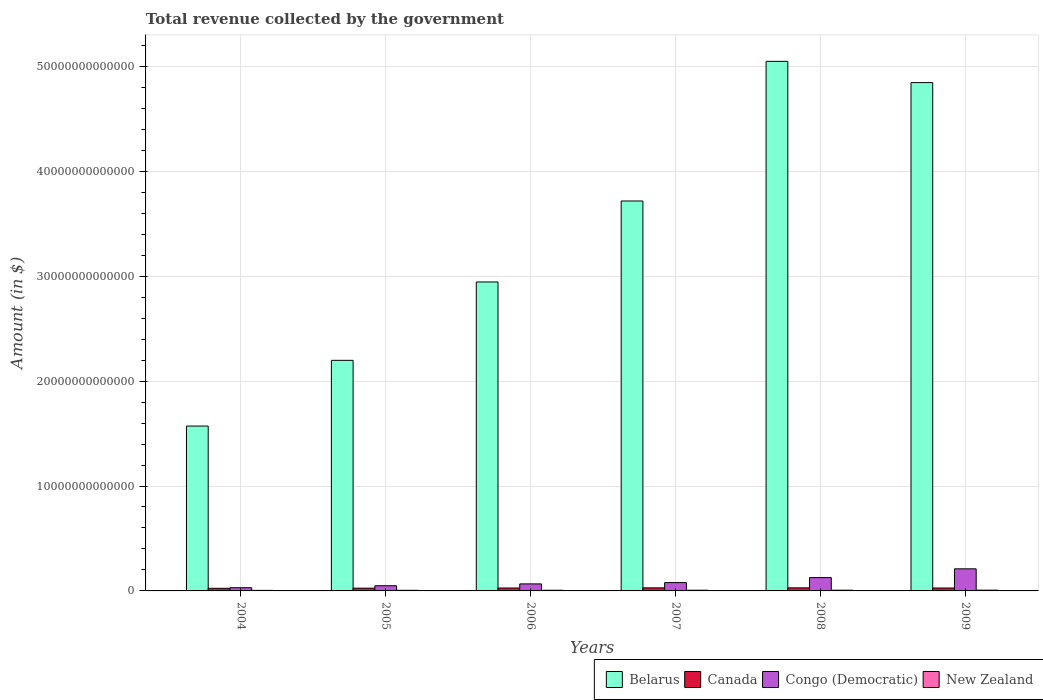How many different coloured bars are there?
Your answer should be very brief. 4. How many groups of bars are there?
Your answer should be compact. 6. What is the label of the 2nd group of bars from the left?
Provide a succinct answer. 2005. In how many cases, is the number of bars for a given year not equal to the number of legend labels?
Offer a terse response. 0. What is the total revenue collected by the government in Belarus in 2006?
Keep it short and to the point. 2.94e+13. Across all years, what is the maximum total revenue collected by the government in New Zealand?
Provide a succinct answer. 7.20e+1. Across all years, what is the minimum total revenue collected by the government in Canada?
Offer a terse response. 2.50e+11. In which year was the total revenue collected by the government in New Zealand minimum?
Offer a very short reply. 2004. What is the total total revenue collected by the government in New Zealand in the graph?
Give a very brief answer. 3.83e+11. What is the difference between the total revenue collected by the government in Belarus in 2005 and that in 2006?
Your response must be concise. -7.47e+12. What is the difference between the total revenue collected by the government in Congo (Democratic) in 2005 and the total revenue collected by the government in Canada in 2009?
Offer a very short reply. 2.18e+11. What is the average total revenue collected by the government in Belarus per year?
Your answer should be compact. 3.39e+13. In the year 2007, what is the difference between the total revenue collected by the government in Belarus and total revenue collected by the government in Congo (Democratic)?
Your answer should be very brief. 3.64e+13. What is the ratio of the total revenue collected by the government in Belarus in 2005 to that in 2009?
Your answer should be very brief. 0.45. Is the difference between the total revenue collected by the government in Belarus in 2004 and 2005 greater than the difference between the total revenue collected by the government in Congo (Democratic) in 2004 and 2005?
Your response must be concise. No. What is the difference between the highest and the second highest total revenue collected by the government in New Zealand?
Offer a very short reply. 3.18e+09. What is the difference between the highest and the lowest total revenue collected by the government in Canada?
Offer a very short reply. 4.32e+1. Is it the case that in every year, the sum of the total revenue collected by the government in New Zealand and total revenue collected by the government in Canada is greater than the sum of total revenue collected by the government in Congo (Democratic) and total revenue collected by the government in Belarus?
Make the answer very short. No. What does the 4th bar from the right in 2008 represents?
Keep it short and to the point. Belarus. Is it the case that in every year, the sum of the total revenue collected by the government in New Zealand and total revenue collected by the government in Belarus is greater than the total revenue collected by the government in Canada?
Offer a terse response. Yes. Are all the bars in the graph horizontal?
Offer a very short reply. No. What is the difference between two consecutive major ticks on the Y-axis?
Keep it short and to the point. 1.00e+13. Where does the legend appear in the graph?
Your answer should be very brief. Bottom right. How many legend labels are there?
Give a very brief answer. 4. What is the title of the graph?
Your answer should be compact. Total revenue collected by the government. What is the label or title of the Y-axis?
Keep it short and to the point. Amount (in $). What is the Amount (in $) of Belarus in 2004?
Make the answer very short. 1.57e+13. What is the Amount (in $) in Canada in 2004?
Provide a short and direct response. 2.50e+11. What is the Amount (in $) of Congo (Democratic) in 2004?
Make the answer very short. 3.06e+11. What is the Amount (in $) of New Zealand in 2004?
Offer a terse response. 5.34e+1. What is the Amount (in $) in Belarus in 2005?
Your answer should be compact. 2.20e+13. What is the Amount (in $) in Canada in 2005?
Your answer should be compact. 2.63e+11. What is the Amount (in $) of Congo (Democratic) in 2005?
Your answer should be compact. 4.95e+11. What is the Amount (in $) in New Zealand in 2005?
Offer a terse response. 5.89e+1. What is the Amount (in $) of Belarus in 2006?
Offer a very short reply. 2.94e+13. What is the Amount (in $) of Canada in 2006?
Provide a succinct answer. 2.77e+11. What is the Amount (in $) of Congo (Democratic) in 2006?
Make the answer very short. 6.69e+11. What is the Amount (in $) in New Zealand in 2006?
Offer a terse response. 6.38e+1. What is the Amount (in $) of Belarus in 2007?
Make the answer very short. 3.72e+13. What is the Amount (in $) of Canada in 2007?
Provide a succinct answer. 2.93e+11. What is the Amount (in $) of Congo (Democratic) in 2007?
Give a very brief answer. 7.94e+11. What is the Amount (in $) in New Zealand in 2007?
Make the answer very short. 6.59e+1. What is the Amount (in $) of Belarus in 2008?
Offer a terse response. 5.05e+13. What is the Amount (in $) in Canada in 2008?
Provide a succinct answer. 2.93e+11. What is the Amount (in $) in Congo (Democratic) in 2008?
Your response must be concise. 1.27e+12. What is the Amount (in $) of New Zealand in 2008?
Provide a short and direct response. 6.88e+1. What is the Amount (in $) of Belarus in 2009?
Offer a very short reply. 4.85e+13. What is the Amount (in $) in Canada in 2009?
Your response must be concise. 2.77e+11. What is the Amount (in $) of Congo (Democratic) in 2009?
Provide a succinct answer. 2.10e+12. What is the Amount (in $) in New Zealand in 2009?
Provide a succinct answer. 7.20e+1. Across all years, what is the maximum Amount (in $) in Belarus?
Offer a terse response. 5.05e+13. Across all years, what is the maximum Amount (in $) of Canada?
Offer a very short reply. 2.93e+11. Across all years, what is the maximum Amount (in $) in Congo (Democratic)?
Your answer should be compact. 2.10e+12. Across all years, what is the maximum Amount (in $) of New Zealand?
Your response must be concise. 7.20e+1. Across all years, what is the minimum Amount (in $) of Belarus?
Offer a terse response. 1.57e+13. Across all years, what is the minimum Amount (in $) of Canada?
Your answer should be very brief. 2.50e+11. Across all years, what is the minimum Amount (in $) of Congo (Democratic)?
Your answer should be compact. 3.06e+11. Across all years, what is the minimum Amount (in $) of New Zealand?
Ensure brevity in your answer.  5.34e+1. What is the total Amount (in $) of Belarus in the graph?
Ensure brevity in your answer.  2.03e+14. What is the total Amount (in $) in Canada in the graph?
Make the answer very short. 1.65e+12. What is the total Amount (in $) of Congo (Democratic) in the graph?
Keep it short and to the point. 5.64e+12. What is the total Amount (in $) of New Zealand in the graph?
Ensure brevity in your answer.  3.83e+11. What is the difference between the Amount (in $) in Belarus in 2004 and that in 2005?
Provide a succinct answer. -6.26e+12. What is the difference between the Amount (in $) in Canada in 2004 and that in 2005?
Ensure brevity in your answer.  -1.37e+1. What is the difference between the Amount (in $) in Congo (Democratic) in 2004 and that in 2005?
Provide a short and direct response. -1.89e+11. What is the difference between the Amount (in $) of New Zealand in 2004 and that in 2005?
Provide a short and direct response. -5.52e+09. What is the difference between the Amount (in $) in Belarus in 2004 and that in 2006?
Ensure brevity in your answer.  -1.37e+13. What is the difference between the Amount (in $) in Canada in 2004 and that in 2006?
Ensure brevity in your answer.  -2.77e+1. What is the difference between the Amount (in $) in Congo (Democratic) in 2004 and that in 2006?
Your answer should be very brief. -3.63e+11. What is the difference between the Amount (in $) in New Zealand in 2004 and that in 2006?
Ensure brevity in your answer.  -1.03e+1. What is the difference between the Amount (in $) in Belarus in 2004 and that in 2007?
Offer a very short reply. -2.15e+13. What is the difference between the Amount (in $) in Canada in 2004 and that in 2007?
Keep it short and to the point. -4.32e+1. What is the difference between the Amount (in $) of Congo (Democratic) in 2004 and that in 2007?
Your answer should be very brief. -4.88e+11. What is the difference between the Amount (in $) in New Zealand in 2004 and that in 2007?
Make the answer very short. -1.24e+1. What is the difference between the Amount (in $) of Belarus in 2004 and that in 2008?
Your answer should be very brief. -3.48e+13. What is the difference between the Amount (in $) in Canada in 2004 and that in 2008?
Your answer should be compact. -4.32e+1. What is the difference between the Amount (in $) in Congo (Democratic) in 2004 and that in 2008?
Give a very brief answer. -9.66e+11. What is the difference between the Amount (in $) in New Zealand in 2004 and that in 2008?
Ensure brevity in your answer.  -1.53e+1. What is the difference between the Amount (in $) of Belarus in 2004 and that in 2009?
Provide a short and direct response. -3.27e+13. What is the difference between the Amount (in $) in Canada in 2004 and that in 2009?
Ensure brevity in your answer.  -2.73e+1. What is the difference between the Amount (in $) in Congo (Democratic) in 2004 and that in 2009?
Make the answer very short. -1.80e+12. What is the difference between the Amount (in $) of New Zealand in 2004 and that in 2009?
Keep it short and to the point. -1.85e+1. What is the difference between the Amount (in $) of Belarus in 2005 and that in 2006?
Provide a succinct answer. -7.47e+12. What is the difference between the Amount (in $) of Canada in 2005 and that in 2006?
Provide a short and direct response. -1.40e+1. What is the difference between the Amount (in $) of Congo (Democratic) in 2005 and that in 2006?
Provide a succinct answer. -1.74e+11. What is the difference between the Amount (in $) of New Zealand in 2005 and that in 2006?
Make the answer very short. -4.82e+09. What is the difference between the Amount (in $) of Belarus in 2005 and that in 2007?
Give a very brief answer. -1.52e+13. What is the difference between the Amount (in $) in Canada in 2005 and that in 2007?
Your answer should be compact. -2.94e+1. What is the difference between the Amount (in $) of Congo (Democratic) in 2005 and that in 2007?
Your answer should be compact. -2.99e+11. What is the difference between the Amount (in $) in New Zealand in 2005 and that in 2007?
Ensure brevity in your answer.  -6.91e+09. What is the difference between the Amount (in $) of Belarus in 2005 and that in 2008?
Your answer should be compact. -2.85e+13. What is the difference between the Amount (in $) of Canada in 2005 and that in 2008?
Provide a short and direct response. -2.95e+1. What is the difference between the Amount (in $) in Congo (Democratic) in 2005 and that in 2008?
Make the answer very short. -7.76e+11. What is the difference between the Amount (in $) in New Zealand in 2005 and that in 2008?
Ensure brevity in your answer.  -9.82e+09. What is the difference between the Amount (in $) of Belarus in 2005 and that in 2009?
Your response must be concise. -2.65e+13. What is the difference between the Amount (in $) in Canada in 2005 and that in 2009?
Make the answer very short. -1.36e+1. What is the difference between the Amount (in $) in Congo (Democratic) in 2005 and that in 2009?
Provide a succinct answer. -1.61e+12. What is the difference between the Amount (in $) of New Zealand in 2005 and that in 2009?
Provide a short and direct response. -1.30e+1. What is the difference between the Amount (in $) in Belarus in 2006 and that in 2007?
Ensure brevity in your answer.  -7.72e+12. What is the difference between the Amount (in $) in Canada in 2006 and that in 2007?
Ensure brevity in your answer.  -1.55e+1. What is the difference between the Amount (in $) of Congo (Democratic) in 2006 and that in 2007?
Offer a terse response. -1.25e+11. What is the difference between the Amount (in $) of New Zealand in 2006 and that in 2007?
Give a very brief answer. -2.09e+09. What is the difference between the Amount (in $) in Belarus in 2006 and that in 2008?
Your answer should be very brief. -2.10e+13. What is the difference between the Amount (in $) of Canada in 2006 and that in 2008?
Make the answer very short. -1.55e+1. What is the difference between the Amount (in $) of Congo (Democratic) in 2006 and that in 2008?
Offer a very short reply. -6.03e+11. What is the difference between the Amount (in $) of New Zealand in 2006 and that in 2008?
Ensure brevity in your answer.  -5.00e+09. What is the difference between the Amount (in $) in Belarus in 2006 and that in 2009?
Provide a succinct answer. -1.90e+13. What is the difference between the Amount (in $) of Canada in 2006 and that in 2009?
Offer a very short reply. 3.30e+08. What is the difference between the Amount (in $) of Congo (Democratic) in 2006 and that in 2009?
Keep it short and to the point. -1.44e+12. What is the difference between the Amount (in $) of New Zealand in 2006 and that in 2009?
Offer a very short reply. -8.18e+09. What is the difference between the Amount (in $) in Belarus in 2007 and that in 2008?
Provide a succinct answer. -1.33e+13. What is the difference between the Amount (in $) of Canada in 2007 and that in 2008?
Make the answer very short. -5.20e+07. What is the difference between the Amount (in $) of Congo (Democratic) in 2007 and that in 2008?
Provide a succinct answer. -4.78e+11. What is the difference between the Amount (in $) in New Zealand in 2007 and that in 2008?
Give a very brief answer. -2.91e+09. What is the difference between the Amount (in $) of Belarus in 2007 and that in 2009?
Offer a very short reply. -1.13e+13. What is the difference between the Amount (in $) of Canada in 2007 and that in 2009?
Keep it short and to the point. 1.58e+1. What is the difference between the Amount (in $) of Congo (Democratic) in 2007 and that in 2009?
Your answer should be compact. -1.31e+12. What is the difference between the Amount (in $) in New Zealand in 2007 and that in 2009?
Keep it short and to the point. -6.09e+09. What is the difference between the Amount (in $) in Belarus in 2008 and that in 2009?
Provide a succinct answer. 2.03e+12. What is the difference between the Amount (in $) in Canada in 2008 and that in 2009?
Make the answer very short. 1.59e+1. What is the difference between the Amount (in $) in Congo (Democratic) in 2008 and that in 2009?
Your answer should be very brief. -8.33e+11. What is the difference between the Amount (in $) of New Zealand in 2008 and that in 2009?
Your answer should be very brief. -3.18e+09. What is the difference between the Amount (in $) of Belarus in 2004 and the Amount (in $) of Canada in 2005?
Ensure brevity in your answer.  1.55e+13. What is the difference between the Amount (in $) in Belarus in 2004 and the Amount (in $) in Congo (Democratic) in 2005?
Give a very brief answer. 1.52e+13. What is the difference between the Amount (in $) in Belarus in 2004 and the Amount (in $) in New Zealand in 2005?
Your answer should be very brief. 1.57e+13. What is the difference between the Amount (in $) of Canada in 2004 and the Amount (in $) of Congo (Democratic) in 2005?
Provide a succinct answer. -2.46e+11. What is the difference between the Amount (in $) in Canada in 2004 and the Amount (in $) in New Zealand in 2005?
Offer a terse response. 1.91e+11. What is the difference between the Amount (in $) in Congo (Democratic) in 2004 and the Amount (in $) in New Zealand in 2005?
Your answer should be compact. 2.47e+11. What is the difference between the Amount (in $) in Belarus in 2004 and the Amount (in $) in Canada in 2006?
Your response must be concise. 1.54e+13. What is the difference between the Amount (in $) in Belarus in 2004 and the Amount (in $) in Congo (Democratic) in 2006?
Your answer should be compact. 1.50e+13. What is the difference between the Amount (in $) of Belarus in 2004 and the Amount (in $) of New Zealand in 2006?
Ensure brevity in your answer.  1.57e+13. What is the difference between the Amount (in $) of Canada in 2004 and the Amount (in $) of Congo (Democratic) in 2006?
Give a very brief answer. -4.19e+11. What is the difference between the Amount (in $) of Canada in 2004 and the Amount (in $) of New Zealand in 2006?
Your response must be concise. 1.86e+11. What is the difference between the Amount (in $) in Congo (Democratic) in 2004 and the Amount (in $) in New Zealand in 2006?
Provide a succinct answer. 2.42e+11. What is the difference between the Amount (in $) of Belarus in 2004 and the Amount (in $) of Canada in 2007?
Give a very brief answer. 1.54e+13. What is the difference between the Amount (in $) in Belarus in 2004 and the Amount (in $) in Congo (Democratic) in 2007?
Provide a short and direct response. 1.49e+13. What is the difference between the Amount (in $) in Belarus in 2004 and the Amount (in $) in New Zealand in 2007?
Offer a terse response. 1.56e+13. What is the difference between the Amount (in $) in Canada in 2004 and the Amount (in $) in Congo (Democratic) in 2007?
Make the answer very short. -5.44e+11. What is the difference between the Amount (in $) of Canada in 2004 and the Amount (in $) of New Zealand in 2007?
Provide a succinct answer. 1.84e+11. What is the difference between the Amount (in $) in Congo (Democratic) in 2004 and the Amount (in $) in New Zealand in 2007?
Your response must be concise. 2.40e+11. What is the difference between the Amount (in $) of Belarus in 2004 and the Amount (in $) of Canada in 2008?
Offer a very short reply. 1.54e+13. What is the difference between the Amount (in $) of Belarus in 2004 and the Amount (in $) of Congo (Democratic) in 2008?
Provide a short and direct response. 1.44e+13. What is the difference between the Amount (in $) of Belarus in 2004 and the Amount (in $) of New Zealand in 2008?
Ensure brevity in your answer.  1.56e+13. What is the difference between the Amount (in $) of Canada in 2004 and the Amount (in $) of Congo (Democratic) in 2008?
Make the answer very short. -1.02e+12. What is the difference between the Amount (in $) in Canada in 2004 and the Amount (in $) in New Zealand in 2008?
Your answer should be compact. 1.81e+11. What is the difference between the Amount (in $) in Congo (Democratic) in 2004 and the Amount (in $) in New Zealand in 2008?
Keep it short and to the point. 2.37e+11. What is the difference between the Amount (in $) in Belarus in 2004 and the Amount (in $) in Canada in 2009?
Your response must be concise. 1.54e+13. What is the difference between the Amount (in $) of Belarus in 2004 and the Amount (in $) of Congo (Democratic) in 2009?
Offer a terse response. 1.36e+13. What is the difference between the Amount (in $) of Belarus in 2004 and the Amount (in $) of New Zealand in 2009?
Your answer should be very brief. 1.56e+13. What is the difference between the Amount (in $) of Canada in 2004 and the Amount (in $) of Congo (Democratic) in 2009?
Provide a succinct answer. -1.86e+12. What is the difference between the Amount (in $) in Canada in 2004 and the Amount (in $) in New Zealand in 2009?
Your response must be concise. 1.78e+11. What is the difference between the Amount (in $) in Congo (Democratic) in 2004 and the Amount (in $) in New Zealand in 2009?
Offer a terse response. 2.34e+11. What is the difference between the Amount (in $) of Belarus in 2005 and the Amount (in $) of Canada in 2006?
Your answer should be very brief. 2.17e+13. What is the difference between the Amount (in $) in Belarus in 2005 and the Amount (in $) in Congo (Democratic) in 2006?
Ensure brevity in your answer.  2.13e+13. What is the difference between the Amount (in $) in Belarus in 2005 and the Amount (in $) in New Zealand in 2006?
Provide a short and direct response. 2.19e+13. What is the difference between the Amount (in $) of Canada in 2005 and the Amount (in $) of Congo (Democratic) in 2006?
Your answer should be very brief. -4.06e+11. What is the difference between the Amount (in $) of Canada in 2005 and the Amount (in $) of New Zealand in 2006?
Your answer should be very brief. 2.00e+11. What is the difference between the Amount (in $) in Congo (Democratic) in 2005 and the Amount (in $) in New Zealand in 2006?
Your response must be concise. 4.31e+11. What is the difference between the Amount (in $) in Belarus in 2005 and the Amount (in $) in Canada in 2007?
Provide a succinct answer. 2.17e+13. What is the difference between the Amount (in $) in Belarus in 2005 and the Amount (in $) in Congo (Democratic) in 2007?
Your answer should be very brief. 2.12e+13. What is the difference between the Amount (in $) in Belarus in 2005 and the Amount (in $) in New Zealand in 2007?
Provide a succinct answer. 2.19e+13. What is the difference between the Amount (in $) in Canada in 2005 and the Amount (in $) in Congo (Democratic) in 2007?
Provide a succinct answer. -5.30e+11. What is the difference between the Amount (in $) in Canada in 2005 and the Amount (in $) in New Zealand in 2007?
Give a very brief answer. 1.98e+11. What is the difference between the Amount (in $) in Congo (Democratic) in 2005 and the Amount (in $) in New Zealand in 2007?
Provide a short and direct response. 4.29e+11. What is the difference between the Amount (in $) of Belarus in 2005 and the Amount (in $) of Canada in 2008?
Your answer should be very brief. 2.17e+13. What is the difference between the Amount (in $) of Belarus in 2005 and the Amount (in $) of Congo (Democratic) in 2008?
Provide a succinct answer. 2.07e+13. What is the difference between the Amount (in $) of Belarus in 2005 and the Amount (in $) of New Zealand in 2008?
Ensure brevity in your answer.  2.19e+13. What is the difference between the Amount (in $) of Canada in 2005 and the Amount (in $) of Congo (Democratic) in 2008?
Offer a terse response. -1.01e+12. What is the difference between the Amount (in $) of Canada in 2005 and the Amount (in $) of New Zealand in 2008?
Offer a terse response. 1.95e+11. What is the difference between the Amount (in $) of Congo (Democratic) in 2005 and the Amount (in $) of New Zealand in 2008?
Your answer should be very brief. 4.26e+11. What is the difference between the Amount (in $) of Belarus in 2005 and the Amount (in $) of Canada in 2009?
Offer a very short reply. 2.17e+13. What is the difference between the Amount (in $) in Belarus in 2005 and the Amount (in $) in Congo (Democratic) in 2009?
Your answer should be very brief. 1.99e+13. What is the difference between the Amount (in $) of Belarus in 2005 and the Amount (in $) of New Zealand in 2009?
Provide a short and direct response. 2.19e+13. What is the difference between the Amount (in $) in Canada in 2005 and the Amount (in $) in Congo (Democratic) in 2009?
Make the answer very short. -1.84e+12. What is the difference between the Amount (in $) of Canada in 2005 and the Amount (in $) of New Zealand in 2009?
Offer a terse response. 1.91e+11. What is the difference between the Amount (in $) of Congo (Democratic) in 2005 and the Amount (in $) of New Zealand in 2009?
Offer a very short reply. 4.23e+11. What is the difference between the Amount (in $) in Belarus in 2006 and the Amount (in $) in Canada in 2007?
Give a very brief answer. 2.92e+13. What is the difference between the Amount (in $) of Belarus in 2006 and the Amount (in $) of Congo (Democratic) in 2007?
Your response must be concise. 2.87e+13. What is the difference between the Amount (in $) in Belarus in 2006 and the Amount (in $) in New Zealand in 2007?
Your answer should be very brief. 2.94e+13. What is the difference between the Amount (in $) of Canada in 2006 and the Amount (in $) of Congo (Democratic) in 2007?
Offer a terse response. -5.16e+11. What is the difference between the Amount (in $) in Canada in 2006 and the Amount (in $) in New Zealand in 2007?
Offer a terse response. 2.11e+11. What is the difference between the Amount (in $) in Congo (Democratic) in 2006 and the Amount (in $) in New Zealand in 2007?
Provide a short and direct response. 6.03e+11. What is the difference between the Amount (in $) in Belarus in 2006 and the Amount (in $) in Canada in 2008?
Give a very brief answer. 2.92e+13. What is the difference between the Amount (in $) of Belarus in 2006 and the Amount (in $) of Congo (Democratic) in 2008?
Keep it short and to the point. 2.82e+13. What is the difference between the Amount (in $) in Belarus in 2006 and the Amount (in $) in New Zealand in 2008?
Ensure brevity in your answer.  2.94e+13. What is the difference between the Amount (in $) in Canada in 2006 and the Amount (in $) in Congo (Democratic) in 2008?
Offer a very short reply. -9.94e+11. What is the difference between the Amount (in $) in Canada in 2006 and the Amount (in $) in New Zealand in 2008?
Make the answer very short. 2.09e+11. What is the difference between the Amount (in $) in Congo (Democratic) in 2006 and the Amount (in $) in New Zealand in 2008?
Your answer should be very brief. 6.00e+11. What is the difference between the Amount (in $) in Belarus in 2006 and the Amount (in $) in Canada in 2009?
Your answer should be very brief. 2.92e+13. What is the difference between the Amount (in $) in Belarus in 2006 and the Amount (in $) in Congo (Democratic) in 2009?
Offer a terse response. 2.73e+13. What is the difference between the Amount (in $) of Belarus in 2006 and the Amount (in $) of New Zealand in 2009?
Your answer should be very brief. 2.94e+13. What is the difference between the Amount (in $) of Canada in 2006 and the Amount (in $) of Congo (Democratic) in 2009?
Your response must be concise. -1.83e+12. What is the difference between the Amount (in $) of Canada in 2006 and the Amount (in $) of New Zealand in 2009?
Provide a short and direct response. 2.05e+11. What is the difference between the Amount (in $) in Congo (Democratic) in 2006 and the Amount (in $) in New Zealand in 2009?
Offer a very short reply. 5.97e+11. What is the difference between the Amount (in $) in Belarus in 2007 and the Amount (in $) in Canada in 2008?
Offer a terse response. 3.69e+13. What is the difference between the Amount (in $) in Belarus in 2007 and the Amount (in $) in Congo (Democratic) in 2008?
Your answer should be compact. 3.59e+13. What is the difference between the Amount (in $) of Belarus in 2007 and the Amount (in $) of New Zealand in 2008?
Offer a very short reply. 3.71e+13. What is the difference between the Amount (in $) in Canada in 2007 and the Amount (in $) in Congo (Democratic) in 2008?
Your response must be concise. -9.79e+11. What is the difference between the Amount (in $) of Canada in 2007 and the Amount (in $) of New Zealand in 2008?
Offer a terse response. 2.24e+11. What is the difference between the Amount (in $) in Congo (Democratic) in 2007 and the Amount (in $) in New Zealand in 2008?
Offer a very short reply. 7.25e+11. What is the difference between the Amount (in $) in Belarus in 2007 and the Amount (in $) in Canada in 2009?
Keep it short and to the point. 3.69e+13. What is the difference between the Amount (in $) of Belarus in 2007 and the Amount (in $) of Congo (Democratic) in 2009?
Your answer should be very brief. 3.51e+13. What is the difference between the Amount (in $) in Belarus in 2007 and the Amount (in $) in New Zealand in 2009?
Your response must be concise. 3.71e+13. What is the difference between the Amount (in $) in Canada in 2007 and the Amount (in $) in Congo (Democratic) in 2009?
Offer a terse response. -1.81e+12. What is the difference between the Amount (in $) of Canada in 2007 and the Amount (in $) of New Zealand in 2009?
Ensure brevity in your answer.  2.21e+11. What is the difference between the Amount (in $) in Congo (Democratic) in 2007 and the Amount (in $) in New Zealand in 2009?
Your answer should be compact. 7.22e+11. What is the difference between the Amount (in $) in Belarus in 2008 and the Amount (in $) in Canada in 2009?
Ensure brevity in your answer.  5.02e+13. What is the difference between the Amount (in $) of Belarus in 2008 and the Amount (in $) of Congo (Democratic) in 2009?
Offer a very short reply. 4.84e+13. What is the difference between the Amount (in $) of Belarus in 2008 and the Amount (in $) of New Zealand in 2009?
Make the answer very short. 5.04e+13. What is the difference between the Amount (in $) of Canada in 2008 and the Amount (in $) of Congo (Democratic) in 2009?
Offer a terse response. -1.81e+12. What is the difference between the Amount (in $) of Canada in 2008 and the Amount (in $) of New Zealand in 2009?
Provide a short and direct response. 2.21e+11. What is the difference between the Amount (in $) in Congo (Democratic) in 2008 and the Amount (in $) in New Zealand in 2009?
Keep it short and to the point. 1.20e+12. What is the average Amount (in $) in Belarus per year?
Offer a terse response. 3.39e+13. What is the average Amount (in $) in Canada per year?
Your answer should be very brief. 2.76e+11. What is the average Amount (in $) of Congo (Democratic) per year?
Your response must be concise. 9.40e+11. What is the average Amount (in $) of New Zealand per year?
Offer a terse response. 6.38e+1. In the year 2004, what is the difference between the Amount (in $) of Belarus and Amount (in $) of Canada?
Give a very brief answer. 1.55e+13. In the year 2004, what is the difference between the Amount (in $) in Belarus and Amount (in $) in Congo (Democratic)?
Give a very brief answer. 1.54e+13. In the year 2004, what is the difference between the Amount (in $) of Belarus and Amount (in $) of New Zealand?
Offer a terse response. 1.57e+13. In the year 2004, what is the difference between the Amount (in $) of Canada and Amount (in $) of Congo (Democratic)?
Offer a very short reply. -5.63e+1. In the year 2004, what is the difference between the Amount (in $) in Canada and Amount (in $) in New Zealand?
Give a very brief answer. 1.96e+11. In the year 2004, what is the difference between the Amount (in $) of Congo (Democratic) and Amount (in $) of New Zealand?
Your response must be concise. 2.53e+11. In the year 2005, what is the difference between the Amount (in $) in Belarus and Amount (in $) in Canada?
Offer a terse response. 2.17e+13. In the year 2005, what is the difference between the Amount (in $) in Belarus and Amount (in $) in Congo (Democratic)?
Offer a very short reply. 2.15e+13. In the year 2005, what is the difference between the Amount (in $) of Belarus and Amount (in $) of New Zealand?
Your answer should be very brief. 2.19e+13. In the year 2005, what is the difference between the Amount (in $) of Canada and Amount (in $) of Congo (Democratic)?
Your answer should be compact. -2.32e+11. In the year 2005, what is the difference between the Amount (in $) of Canada and Amount (in $) of New Zealand?
Your response must be concise. 2.04e+11. In the year 2005, what is the difference between the Amount (in $) in Congo (Democratic) and Amount (in $) in New Zealand?
Offer a very short reply. 4.36e+11. In the year 2006, what is the difference between the Amount (in $) of Belarus and Amount (in $) of Canada?
Make the answer very short. 2.92e+13. In the year 2006, what is the difference between the Amount (in $) of Belarus and Amount (in $) of Congo (Democratic)?
Provide a short and direct response. 2.88e+13. In the year 2006, what is the difference between the Amount (in $) in Belarus and Amount (in $) in New Zealand?
Provide a short and direct response. 2.94e+13. In the year 2006, what is the difference between the Amount (in $) in Canada and Amount (in $) in Congo (Democratic)?
Your answer should be compact. -3.92e+11. In the year 2006, what is the difference between the Amount (in $) of Canada and Amount (in $) of New Zealand?
Keep it short and to the point. 2.14e+11. In the year 2006, what is the difference between the Amount (in $) of Congo (Democratic) and Amount (in $) of New Zealand?
Offer a terse response. 6.05e+11. In the year 2007, what is the difference between the Amount (in $) in Belarus and Amount (in $) in Canada?
Offer a terse response. 3.69e+13. In the year 2007, what is the difference between the Amount (in $) in Belarus and Amount (in $) in Congo (Democratic)?
Give a very brief answer. 3.64e+13. In the year 2007, what is the difference between the Amount (in $) of Belarus and Amount (in $) of New Zealand?
Offer a terse response. 3.71e+13. In the year 2007, what is the difference between the Amount (in $) of Canada and Amount (in $) of Congo (Democratic)?
Your answer should be very brief. -5.01e+11. In the year 2007, what is the difference between the Amount (in $) of Canada and Amount (in $) of New Zealand?
Your answer should be compact. 2.27e+11. In the year 2007, what is the difference between the Amount (in $) in Congo (Democratic) and Amount (in $) in New Zealand?
Your answer should be compact. 7.28e+11. In the year 2008, what is the difference between the Amount (in $) of Belarus and Amount (in $) of Canada?
Offer a very short reply. 5.02e+13. In the year 2008, what is the difference between the Amount (in $) in Belarus and Amount (in $) in Congo (Democratic)?
Offer a terse response. 4.92e+13. In the year 2008, what is the difference between the Amount (in $) of Belarus and Amount (in $) of New Zealand?
Give a very brief answer. 5.04e+13. In the year 2008, what is the difference between the Amount (in $) of Canada and Amount (in $) of Congo (Democratic)?
Your answer should be very brief. -9.79e+11. In the year 2008, what is the difference between the Amount (in $) of Canada and Amount (in $) of New Zealand?
Make the answer very short. 2.24e+11. In the year 2008, what is the difference between the Amount (in $) of Congo (Democratic) and Amount (in $) of New Zealand?
Keep it short and to the point. 1.20e+12. In the year 2009, what is the difference between the Amount (in $) in Belarus and Amount (in $) in Canada?
Your answer should be compact. 4.82e+13. In the year 2009, what is the difference between the Amount (in $) in Belarus and Amount (in $) in Congo (Democratic)?
Offer a terse response. 4.63e+13. In the year 2009, what is the difference between the Amount (in $) in Belarus and Amount (in $) in New Zealand?
Ensure brevity in your answer.  4.84e+13. In the year 2009, what is the difference between the Amount (in $) in Canada and Amount (in $) in Congo (Democratic)?
Make the answer very short. -1.83e+12. In the year 2009, what is the difference between the Amount (in $) in Canada and Amount (in $) in New Zealand?
Keep it short and to the point. 2.05e+11. In the year 2009, what is the difference between the Amount (in $) in Congo (Democratic) and Amount (in $) in New Zealand?
Offer a terse response. 2.03e+12. What is the ratio of the Amount (in $) in Belarus in 2004 to that in 2005?
Provide a succinct answer. 0.71. What is the ratio of the Amount (in $) of Canada in 2004 to that in 2005?
Provide a succinct answer. 0.95. What is the ratio of the Amount (in $) of Congo (Democratic) in 2004 to that in 2005?
Your response must be concise. 0.62. What is the ratio of the Amount (in $) in New Zealand in 2004 to that in 2005?
Your answer should be very brief. 0.91. What is the ratio of the Amount (in $) in Belarus in 2004 to that in 2006?
Provide a short and direct response. 0.53. What is the ratio of the Amount (in $) of Canada in 2004 to that in 2006?
Ensure brevity in your answer.  0.9. What is the ratio of the Amount (in $) of Congo (Democratic) in 2004 to that in 2006?
Ensure brevity in your answer.  0.46. What is the ratio of the Amount (in $) in New Zealand in 2004 to that in 2006?
Your answer should be compact. 0.84. What is the ratio of the Amount (in $) of Belarus in 2004 to that in 2007?
Offer a very short reply. 0.42. What is the ratio of the Amount (in $) in Canada in 2004 to that in 2007?
Offer a very short reply. 0.85. What is the ratio of the Amount (in $) of Congo (Democratic) in 2004 to that in 2007?
Your response must be concise. 0.39. What is the ratio of the Amount (in $) of New Zealand in 2004 to that in 2007?
Provide a succinct answer. 0.81. What is the ratio of the Amount (in $) in Belarus in 2004 to that in 2008?
Make the answer very short. 0.31. What is the ratio of the Amount (in $) of Canada in 2004 to that in 2008?
Offer a very short reply. 0.85. What is the ratio of the Amount (in $) of Congo (Democratic) in 2004 to that in 2008?
Your answer should be compact. 0.24. What is the ratio of the Amount (in $) of New Zealand in 2004 to that in 2008?
Provide a succinct answer. 0.78. What is the ratio of the Amount (in $) in Belarus in 2004 to that in 2009?
Ensure brevity in your answer.  0.32. What is the ratio of the Amount (in $) in Canada in 2004 to that in 2009?
Your answer should be compact. 0.9. What is the ratio of the Amount (in $) of Congo (Democratic) in 2004 to that in 2009?
Your answer should be very brief. 0.15. What is the ratio of the Amount (in $) in New Zealand in 2004 to that in 2009?
Offer a very short reply. 0.74. What is the ratio of the Amount (in $) in Belarus in 2005 to that in 2006?
Your answer should be compact. 0.75. What is the ratio of the Amount (in $) of Canada in 2005 to that in 2006?
Your answer should be very brief. 0.95. What is the ratio of the Amount (in $) of Congo (Democratic) in 2005 to that in 2006?
Ensure brevity in your answer.  0.74. What is the ratio of the Amount (in $) in New Zealand in 2005 to that in 2006?
Your answer should be compact. 0.92. What is the ratio of the Amount (in $) of Belarus in 2005 to that in 2007?
Offer a terse response. 0.59. What is the ratio of the Amount (in $) in Canada in 2005 to that in 2007?
Your response must be concise. 0.9. What is the ratio of the Amount (in $) in Congo (Democratic) in 2005 to that in 2007?
Keep it short and to the point. 0.62. What is the ratio of the Amount (in $) of New Zealand in 2005 to that in 2007?
Offer a terse response. 0.9. What is the ratio of the Amount (in $) in Belarus in 2005 to that in 2008?
Keep it short and to the point. 0.44. What is the ratio of the Amount (in $) of Canada in 2005 to that in 2008?
Provide a short and direct response. 0.9. What is the ratio of the Amount (in $) of Congo (Democratic) in 2005 to that in 2008?
Your response must be concise. 0.39. What is the ratio of the Amount (in $) of Belarus in 2005 to that in 2009?
Offer a very short reply. 0.45. What is the ratio of the Amount (in $) of Canada in 2005 to that in 2009?
Make the answer very short. 0.95. What is the ratio of the Amount (in $) of Congo (Democratic) in 2005 to that in 2009?
Offer a very short reply. 0.24. What is the ratio of the Amount (in $) of New Zealand in 2005 to that in 2009?
Provide a succinct answer. 0.82. What is the ratio of the Amount (in $) of Belarus in 2006 to that in 2007?
Offer a terse response. 0.79. What is the ratio of the Amount (in $) of Canada in 2006 to that in 2007?
Ensure brevity in your answer.  0.95. What is the ratio of the Amount (in $) in Congo (Democratic) in 2006 to that in 2007?
Your answer should be compact. 0.84. What is the ratio of the Amount (in $) in New Zealand in 2006 to that in 2007?
Ensure brevity in your answer.  0.97. What is the ratio of the Amount (in $) in Belarus in 2006 to that in 2008?
Offer a terse response. 0.58. What is the ratio of the Amount (in $) of Canada in 2006 to that in 2008?
Your response must be concise. 0.95. What is the ratio of the Amount (in $) in Congo (Democratic) in 2006 to that in 2008?
Your answer should be very brief. 0.53. What is the ratio of the Amount (in $) of New Zealand in 2006 to that in 2008?
Your answer should be compact. 0.93. What is the ratio of the Amount (in $) of Belarus in 2006 to that in 2009?
Ensure brevity in your answer.  0.61. What is the ratio of the Amount (in $) of Canada in 2006 to that in 2009?
Your answer should be very brief. 1. What is the ratio of the Amount (in $) of Congo (Democratic) in 2006 to that in 2009?
Keep it short and to the point. 0.32. What is the ratio of the Amount (in $) in New Zealand in 2006 to that in 2009?
Your answer should be compact. 0.89. What is the ratio of the Amount (in $) in Belarus in 2007 to that in 2008?
Offer a very short reply. 0.74. What is the ratio of the Amount (in $) in Congo (Democratic) in 2007 to that in 2008?
Keep it short and to the point. 0.62. What is the ratio of the Amount (in $) in New Zealand in 2007 to that in 2008?
Offer a terse response. 0.96. What is the ratio of the Amount (in $) in Belarus in 2007 to that in 2009?
Provide a succinct answer. 0.77. What is the ratio of the Amount (in $) in Canada in 2007 to that in 2009?
Your answer should be very brief. 1.06. What is the ratio of the Amount (in $) in Congo (Democratic) in 2007 to that in 2009?
Your answer should be very brief. 0.38. What is the ratio of the Amount (in $) in New Zealand in 2007 to that in 2009?
Your response must be concise. 0.92. What is the ratio of the Amount (in $) in Belarus in 2008 to that in 2009?
Your response must be concise. 1.04. What is the ratio of the Amount (in $) of Canada in 2008 to that in 2009?
Your answer should be compact. 1.06. What is the ratio of the Amount (in $) in Congo (Democratic) in 2008 to that in 2009?
Your response must be concise. 0.6. What is the ratio of the Amount (in $) of New Zealand in 2008 to that in 2009?
Your response must be concise. 0.96. What is the difference between the highest and the second highest Amount (in $) of Belarus?
Your answer should be compact. 2.03e+12. What is the difference between the highest and the second highest Amount (in $) of Canada?
Your answer should be compact. 5.20e+07. What is the difference between the highest and the second highest Amount (in $) of Congo (Democratic)?
Keep it short and to the point. 8.33e+11. What is the difference between the highest and the second highest Amount (in $) in New Zealand?
Your answer should be compact. 3.18e+09. What is the difference between the highest and the lowest Amount (in $) of Belarus?
Your answer should be very brief. 3.48e+13. What is the difference between the highest and the lowest Amount (in $) in Canada?
Your answer should be very brief. 4.32e+1. What is the difference between the highest and the lowest Amount (in $) of Congo (Democratic)?
Provide a short and direct response. 1.80e+12. What is the difference between the highest and the lowest Amount (in $) in New Zealand?
Provide a succinct answer. 1.85e+1. 